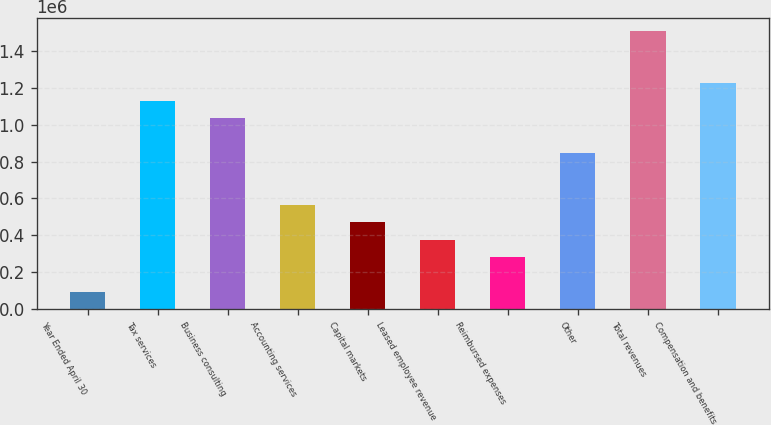Convert chart. <chart><loc_0><loc_0><loc_500><loc_500><bar_chart><fcel>Year Ended April 30<fcel>Tax services<fcel>Business consulting<fcel>Accounting services<fcel>Capital markets<fcel>Leased employee revenue<fcel>Reimbursed expenses<fcel>Other<fcel>Total revenues<fcel>Compensation and benefits<nl><fcel>94177.1<fcel>1.13002e+06<fcel>1.03585e+06<fcel>565015<fcel>470848<fcel>376680<fcel>282512<fcel>847518<fcel>1.50669e+06<fcel>1.22419e+06<nl></chart> 